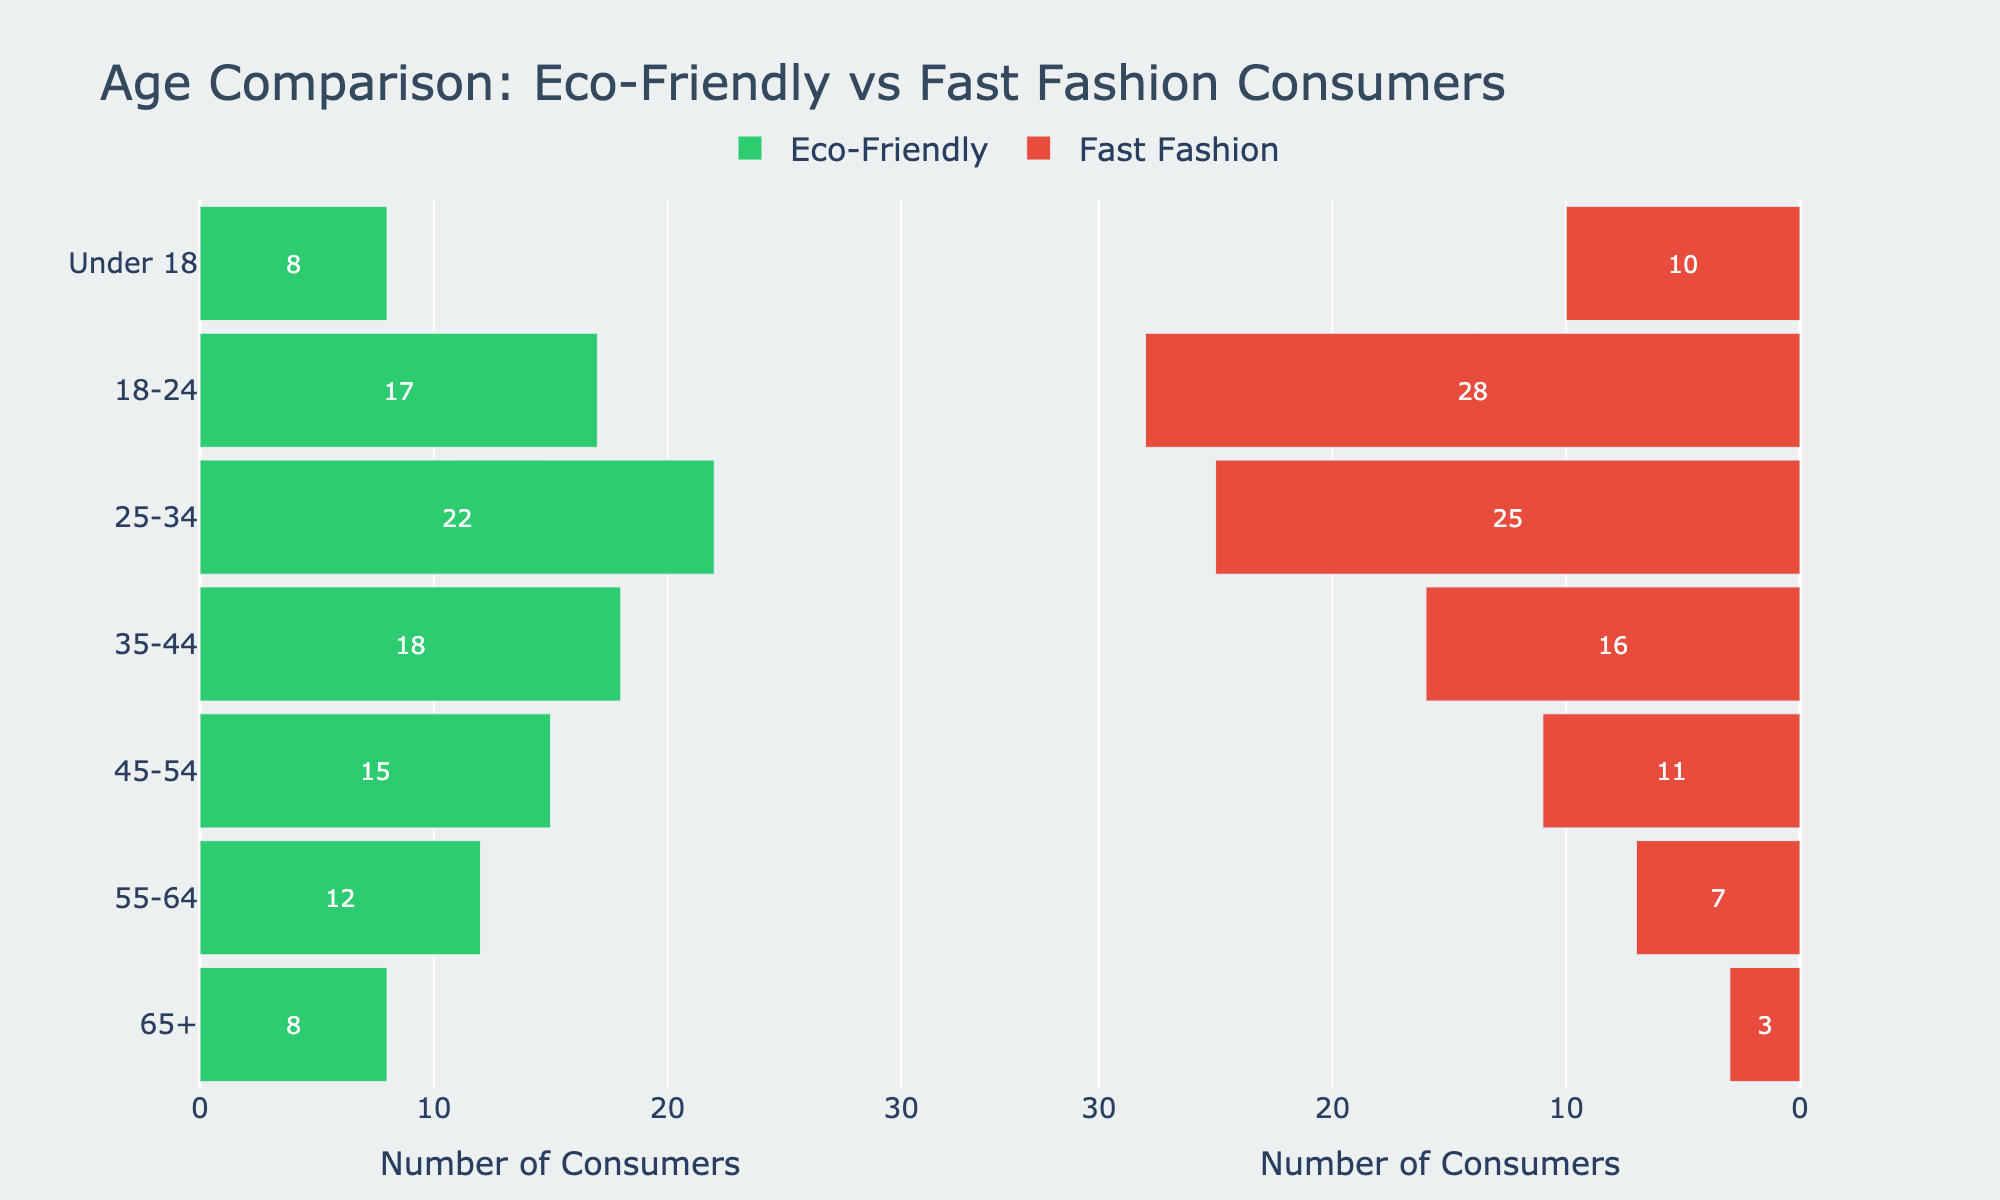What is the age group with the highest number of eco-friendly consumers? The figure shows bars representing the number of eco-friendly consumers across different age groups. The age group with the longest bar is 25-34.
Answer: 25-34 Which age group has more fast fashion customers than eco-friendly consumers? By comparing the length of the bars, the 18-24 and 25-34 age groups have longer bars for fast fashion customers than eco-friendly consumers.
Answer: 18-24, 25-34 What is the total number of consumers aged 65 and older for both categories? Add the number of eco-friendly consumers aged 65+ and fast fashion customers aged 65+. 8 (eco-friendly) + 3 (fast fashion) = 11.
Answer: 11 Which age group has the smallest difference between the number of eco-friendly consumers and fast fashion customers? Calculate the differences for each age group: 65+ (5), 55-64 (5), 45-54 (4), 35-44 (2), 25-34 (3), 18-24 (11), Under 18 (2). The smallest difference is in the 35-44 and Under 18 age groups.
Answer: 35-44, Under 18 What is the combined number of consumers under 18 in both categories? Add the number of eco-friendly consumers and fast fashion customers for the Under 18 age group. 8 + 10 = 18.
Answer: 18 Which age group has the highest number of fast fashion customers? Observe the bars for fast fashion customers by age group. The longest bar corresponds to the 18-24 age group.
Answer: 18-24 In which age group is the number of fast fashion customers twice or more than the number of eco-friendly consumers? Compare the number of fast fashion customers to twice the number of eco-friendly consumers for each group. Only the 18-24 group has 28 fast fashion customers, which is more than twice the 17 eco-friendly consumers.
Answer: 18-24 Which age group shows a higher number of eco-friendly consumers as compared to fast fashion customers? Compare the lengths of the bars for each age group to identify those where the eco-friendly consumer bar is longer. This applies to the 65+, 55-64, 45-54, and 35-44 age groups.
Answer: 65+, 55-64, 45-54, 35-44 